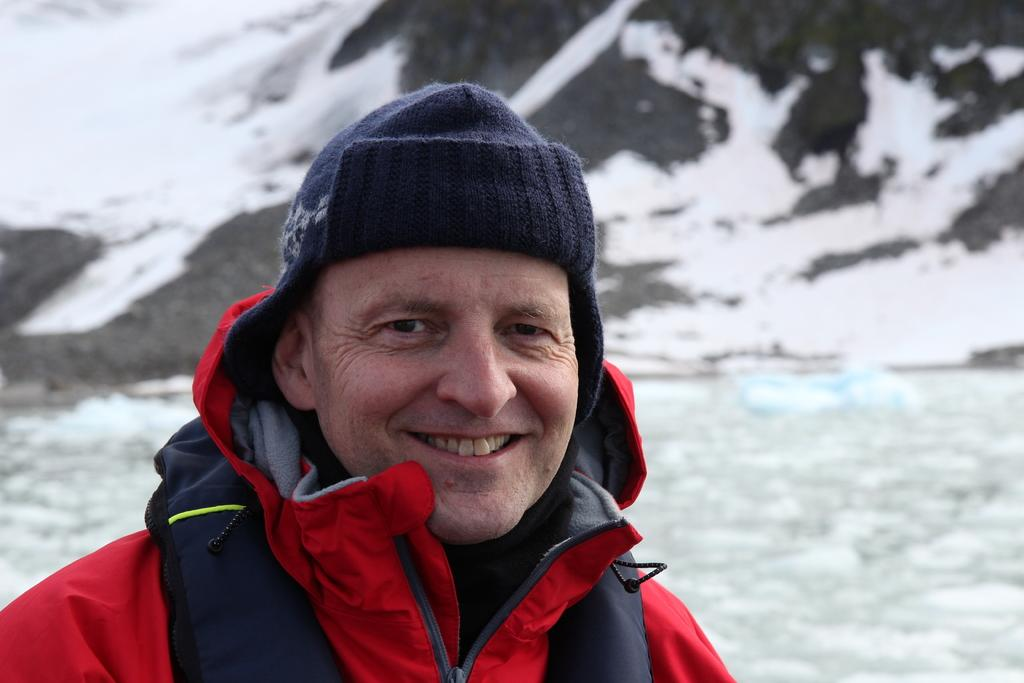Who is present in the image? There is a man in the image. What is the man's facial expression? The man is smiling. What clothing items is the man wearing? The man is wearing a jacket and a cap. Can you describe the background of the image? The background of the image is blurry, and there is water and snow visible. What type of knowledge can be gained from the appliance in the image? There is no appliance present in the image, so no knowledge can be gained from it. 